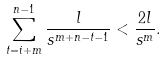Convert formula to latex. <formula><loc_0><loc_0><loc_500><loc_500>\sum _ { t = i + m } ^ { n - 1 } \frac { l } { s ^ { m + n - t - 1 } } < \frac { 2 l } { s ^ { m } } .</formula> 